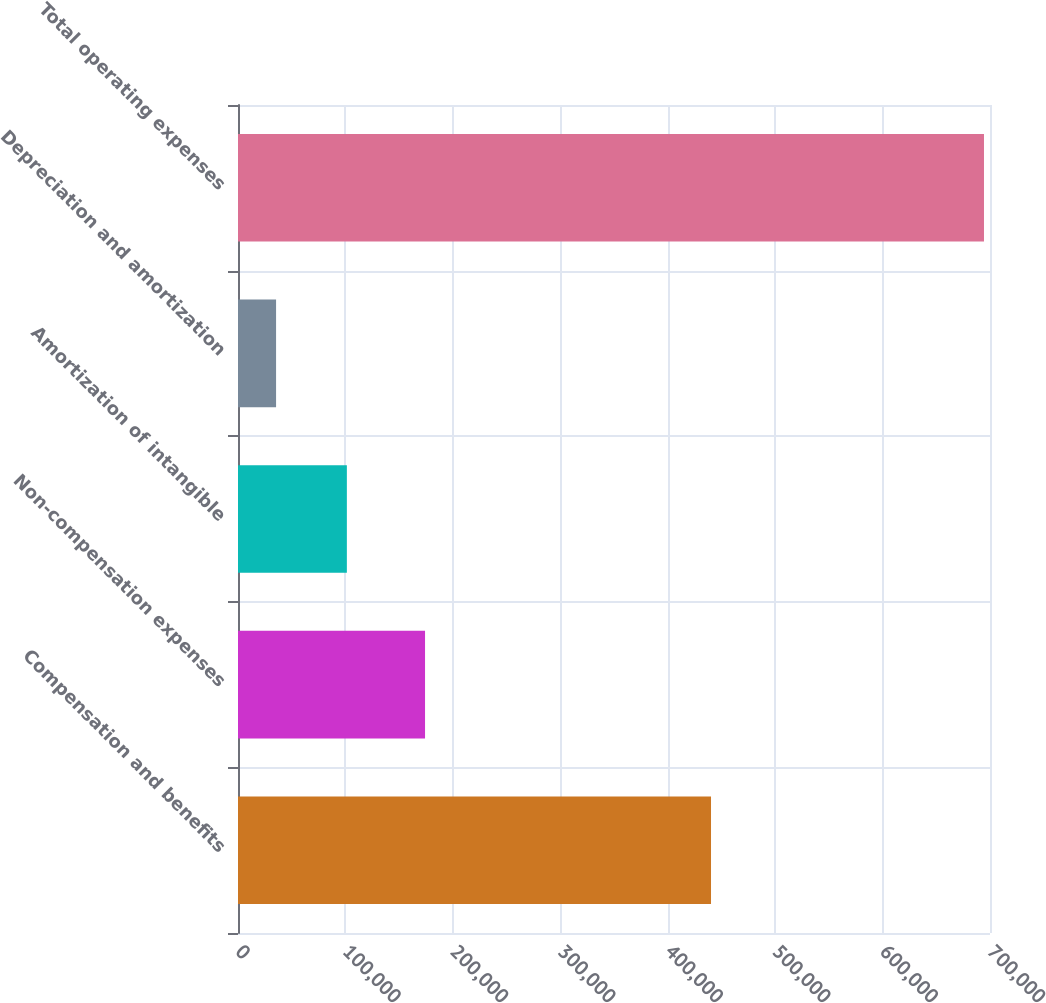Convert chart to OTSL. <chart><loc_0><loc_0><loc_500><loc_500><bar_chart><fcel>Compensation and benefits<fcel>Non-compensation expenses<fcel>Amortization of intangible<fcel>Depreciation and amortization<fcel>Total operating expenses<nl><fcel>440307<fcel>174108<fcel>101336<fcel>35440<fcel>694402<nl></chart> 